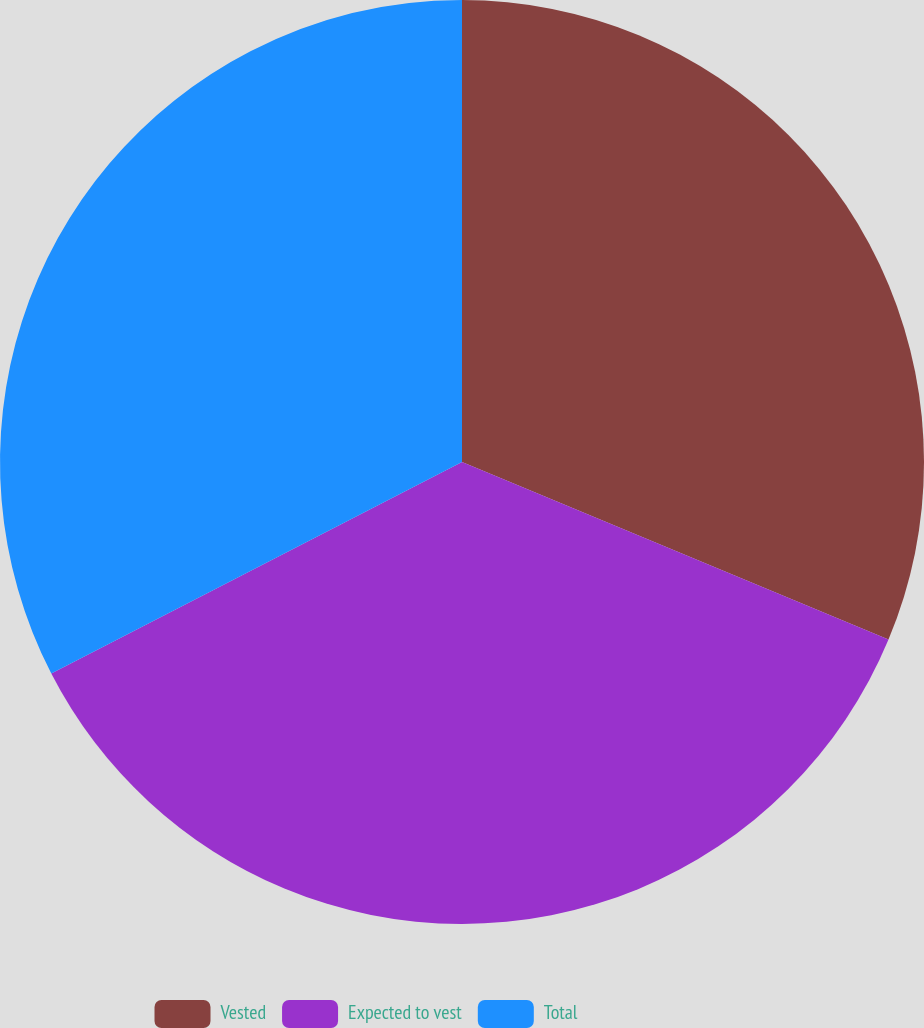Convert chart. <chart><loc_0><loc_0><loc_500><loc_500><pie_chart><fcel>Vested<fcel>Expected to vest<fcel>Total<nl><fcel>31.28%<fcel>36.15%<fcel>32.57%<nl></chart> 